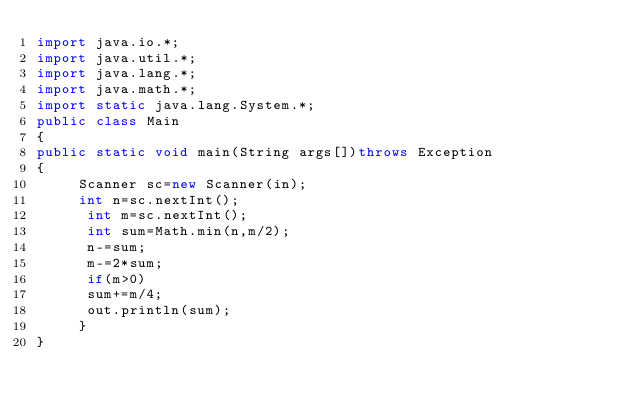<code> <loc_0><loc_0><loc_500><loc_500><_Java_>import java.io.*;
import java.util.*;
import java.lang.*;
import java.math.*;
import static java.lang.System.*;
public class Main
{
public static void main(String args[])throws Exception
{
     Scanner sc=new Scanner(in);
     int n=sc.nextInt();
      int m=sc.nextInt();
      int sum=Math.min(n,m/2);
      n-=sum;
      m-=2*sum;
      if(m>0)
      sum+=m/4;
      out.println(sum);
     }
}</code> 